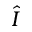Convert formula to latex. <formula><loc_0><loc_0><loc_500><loc_500>\hat { I }</formula> 